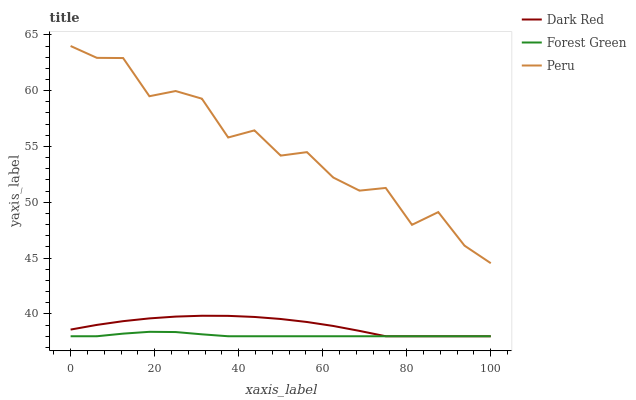Does Forest Green have the minimum area under the curve?
Answer yes or no. Yes. Does Peru have the maximum area under the curve?
Answer yes or no. Yes. Does Peru have the minimum area under the curve?
Answer yes or no. No. Does Forest Green have the maximum area under the curve?
Answer yes or no. No. Is Forest Green the smoothest?
Answer yes or no. Yes. Is Peru the roughest?
Answer yes or no. Yes. Is Peru the smoothest?
Answer yes or no. No. Is Forest Green the roughest?
Answer yes or no. No. Does Dark Red have the lowest value?
Answer yes or no. Yes. Does Peru have the lowest value?
Answer yes or no. No. Does Peru have the highest value?
Answer yes or no. Yes. Does Forest Green have the highest value?
Answer yes or no. No. Is Dark Red less than Peru?
Answer yes or no. Yes. Is Peru greater than Forest Green?
Answer yes or no. Yes. Does Forest Green intersect Dark Red?
Answer yes or no. Yes. Is Forest Green less than Dark Red?
Answer yes or no. No. Is Forest Green greater than Dark Red?
Answer yes or no. No. Does Dark Red intersect Peru?
Answer yes or no. No. 